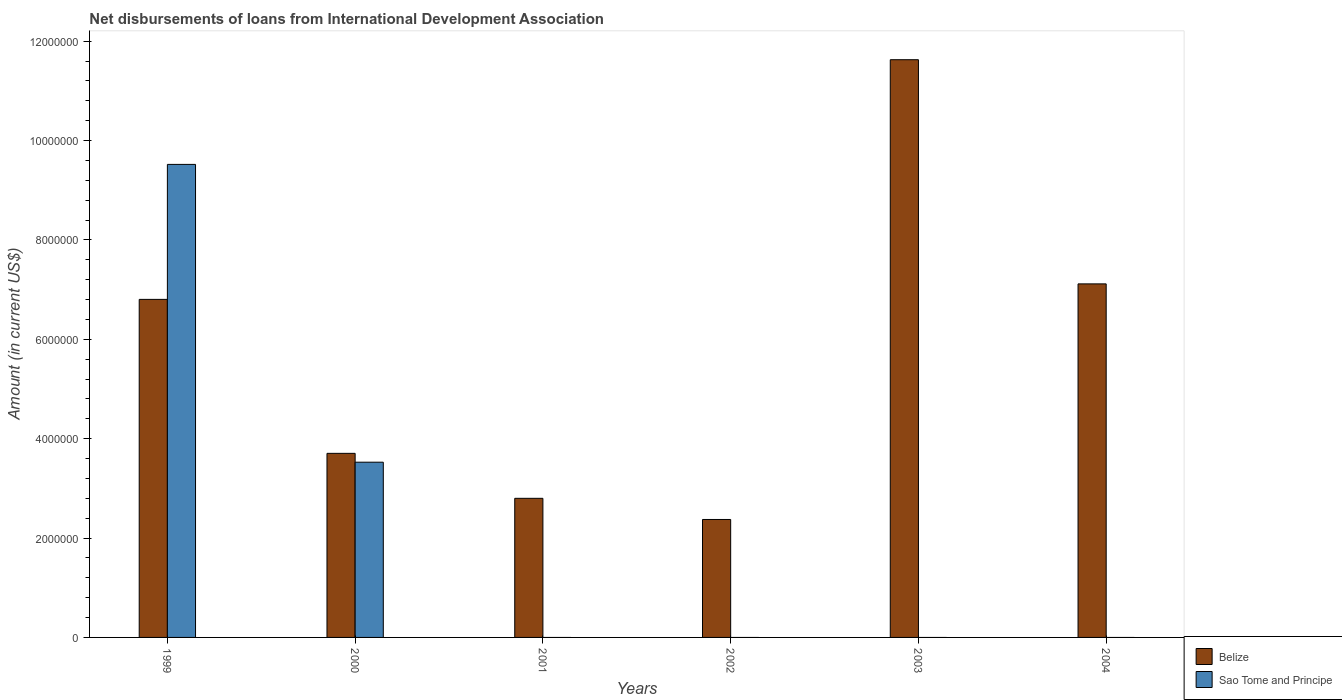Are the number of bars per tick equal to the number of legend labels?
Provide a succinct answer. No. Are the number of bars on each tick of the X-axis equal?
Provide a short and direct response. No. In how many cases, is the number of bars for a given year not equal to the number of legend labels?
Ensure brevity in your answer.  4. What is the amount of loans disbursed in Belize in 2003?
Your answer should be very brief. 1.16e+07. Across all years, what is the maximum amount of loans disbursed in Sao Tome and Principe?
Offer a terse response. 9.52e+06. Across all years, what is the minimum amount of loans disbursed in Sao Tome and Principe?
Give a very brief answer. 0. What is the total amount of loans disbursed in Belize in the graph?
Your response must be concise. 3.44e+07. What is the difference between the amount of loans disbursed in Belize in 2000 and that in 2001?
Your answer should be compact. 9.05e+05. What is the difference between the amount of loans disbursed in Sao Tome and Principe in 2003 and the amount of loans disbursed in Belize in 2002?
Keep it short and to the point. -2.37e+06. What is the average amount of loans disbursed in Sao Tome and Principe per year?
Offer a terse response. 2.17e+06. In the year 1999, what is the difference between the amount of loans disbursed in Sao Tome and Principe and amount of loans disbursed in Belize?
Your answer should be compact. 2.72e+06. What is the ratio of the amount of loans disbursed in Belize in 2001 to that in 2004?
Your response must be concise. 0.39. What is the difference between the highest and the second highest amount of loans disbursed in Belize?
Give a very brief answer. 4.51e+06. What is the difference between the highest and the lowest amount of loans disbursed in Belize?
Ensure brevity in your answer.  9.25e+06. Is the sum of the amount of loans disbursed in Belize in 2003 and 2004 greater than the maximum amount of loans disbursed in Sao Tome and Principe across all years?
Ensure brevity in your answer.  Yes. Are all the bars in the graph horizontal?
Your answer should be very brief. No. Are the values on the major ticks of Y-axis written in scientific E-notation?
Your answer should be compact. No. Where does the legend appear in the graph?
Your answer should be very brief. Bottom right. How are the legend labels stacked?
Give a very brief answer. Vertical. What is the title of the graph?
Give a very brief answer. Net disbursements of loans from International Development Association. What is the Amount (in current US$) of Belize in 1999?
Ensure brevity in your answer.  6.80e+06. What is the Amount (in current US$) in Sao Tome and Principe in 1999?
Provide a succinct answer. 9.52e+06. What is the Amount (in current US$) in Belize in 2000?
Provide a succinct answer. 3.70e+06. What is the Amount (in current US$) in Sao Tome and Principe in 2000?
Your answer should be compact. 3.53e+06. What is the Amount (in current US$) in Belize in 2001?
Offer a very short reply. 2.80e+06. What is the Amount (in current US$) in Sao Tome and Principe in 2001?
Ensure brevity in your answer.  0. What is the Amount (in current US$) in Belize in 2002?
Your answer should be very brief. 2.37e+06. What is the Amount (in current US$) in Sao Tome and Principe in 2002?
Offer a very short reply. 0. What is the Amount (in current US$) in Belize in 2003?
Your answer should be compact. 1.16e+07. What is the Amount (in current US$) of Belize in 2004?
Give a very brief answer. 7.12e+06. What is the Amount (in current US$) in Sao Tome and Principe in 2004?
Your answer should be compact. 0. Across all years, what is the maximum Amount (in current US$) of Belize?
Your answer should be very brief. 1.16e+07. Across all years, what is the maximum Amount (in current US$) in Sao Tome and Principe?
Your response must be concise. 9.52e+06. Across all years, what is the minimum Amount (in current US$) in Belize?
Ensure brevity in your answer.  2.37e+06. What is the total Amount (in current US$) of Belize in the graph?
Provide a short and direct response. 3.44e+07. What is the total Amount (in current US$) in Sao Tome and Principe in the graph?
Ensure brevity in your answer.  1.30e+07. What is the difference between the Amount (in current US$) of Belize in 1999 and that in 2000?
Ensure brevity in your answer.  3.10e+06. What is the difference between the Amount (in current US$) in Sao Tome and Principe in 1999 and that in 2000?
Offer a very short reply. 5.99e+06. What is the difference between the Amount (in current US$) in Belize in 1999 and that in 2001?
Your response must be concise. 4.00e+06. What is the difference between the Amount (in current US$) in Belize in 1999 and that in 2002?
Provide a short and direct response. 4.43e+06. What is the difference between the Amount (in current US$) of Belize in 1999 and that in 2003?
Give a very brief answer. -4.82e+06. What is the difference between the Amount (in current US$) of Belize in 1999 and that in 2004?
Your answer should be compact. -3.12e+05. What is the difference between the Amount (in current US$) in Belize in 2000 and that in 2001?
Offer a terse response. 9.05e+05. What is the difference between the Amount (in current US$) of Belize in 2000 and that in 2002?
Your answer should be compact. 1.33e+06. What is the difference between the Amount (in current US$) in Belize in 2000 and that in 2003?
Offer a very short reply. -7.92e+06. What is the difference between the Amount (in current US$) of Belize in 2000 and that in 2004?
Offer a very short reply. -3.41e+06. What is the difference between the Amount (in current US$) in Belize in 2001 and that in 2002?
Provide a succinct answer. 4.26e+05. What is the difference between the Amount (in current US$) of Belize in 2001 and that in 2003?
Provide a succinct answer. -8.83e+06. What is the difference between the Amount (in current US$) of Belize in 2001 and that in 2004?
Keep it short and to the point. -4.32e+06. What is the difference between the Amount (in current US$) in Belize in 2002 and that in 2003?
Give a very brief answer. -9.25e+06. What is the difference between the Amount (in current US$) of Belize in 2002 and that in 2004?
Provide a short and direct response. -4.74e+06. What is the difference between the Amount (in current US$) in Belize in 2003 and that in 2004?
Your answer should be compact. 4.51e+06. What is the difference between the Amount (in current US$) in Belize in 1999 and the Amount (in current US$) in Sao Tome and Principe in 2000?
Keep it short and to the point. 3.28e+06. What is the average Amount (in current US$) of Belize per year?
Give a very brief answer. 5.74e+06. What is the average Amount (in current US$) of Sao Tome and Principe per year?
Your response must be concise. 2.17e+06. In the year 1999, what is the difference between the Amount (in current US$) in Belize and Amount (in current US$) in Sao Tome and Principe?
Your answer should be very brief. -2.72e+06. In the year 2000, what is the difference between the Amount (in current US$) of Belize and Amount (in current US$) of Sao Tome and Principe?
Offer a terse response. 1.78e+05. What is the ratio of the Amount (in current US$) of Belize in 1999 to that in 2000?
Give a very brief answer. 1.84. What is the ratio of the Amount (in current US$) in Sao Tome and Principe in 1999 to that in 2000?
Offer a very short reply. 2.7. What is the ratio of the Amount (in current US$) of Belize in 1999 to that in 2001?
Ensure brevity in your answer.  2.43. What is the ratio of the Amount (in current US$) of Belize in 1999 to that in 2002?
Make the answer very short. 2.87. What is the ratio of the Amount (in current US$) in Belize in 1999 to that in 2003?
Provide a succinct answer. 0.59. What is the ratio of the Amount (in current US$) of Belize in 1999 to that in 2004?
Your answer should be very brief. 0.96. What is the ratio of the Amount (in current US$) of Belize in 2000 to that in 2001?
Make the answer very short. 1.32. What is the ratio of the Amount (in current US$) of Belize in 2000 to that in 2002?
Provide a short and direct response. 1.56. What is the ratio of the Amount (in current US$) in Belize in 2000 to that in 2003?
Keep it short and to the point. 0.32. What is the ratio of the Amount (in current US$) in Belize in 2000 to that in 2004?
Give a very brief answer. 0.52. What is the ratio of the Amount (in current US$) in Belize in 2001 to that in 2002?
Offer a very short reply. 1.18. What is the ratio of the Amount (in current US$) of Belize in 2001 to that in 2003?
Your answer should be very brief. 0.24. What is the ratio of the Amount (in current US$) in Belize in 2001 to that in 2004?
Keep it short and to the point. 0.39. What is the ratio of the Amount (in current US$) of Belize in 2002 to that in 2003?
Your answer should be very brief. 0.2. What is the ratio of the Amount (in current US$) of Belize in 2002 to that in 2004?
Ensure brevity in your answer.  0.33. What is the ratio of the Amount (in current US$) in Belize in 2003 to that in 2004?
Keep it short and to the point. 1.63. What is the difference between the highest and the second highest Amount (in current US$) in Belize?
Offer a terse response. 4.51e+06. What is the difference between the highest and the lowest Amount (in current US$) in Belize?
Provide a short and direct response. 9.25e+06. What is the difference between the highest and the lowest Amount (in current US$) in Sao Tome and Principe?
Provide a short and direct response. 9.52e+06. 